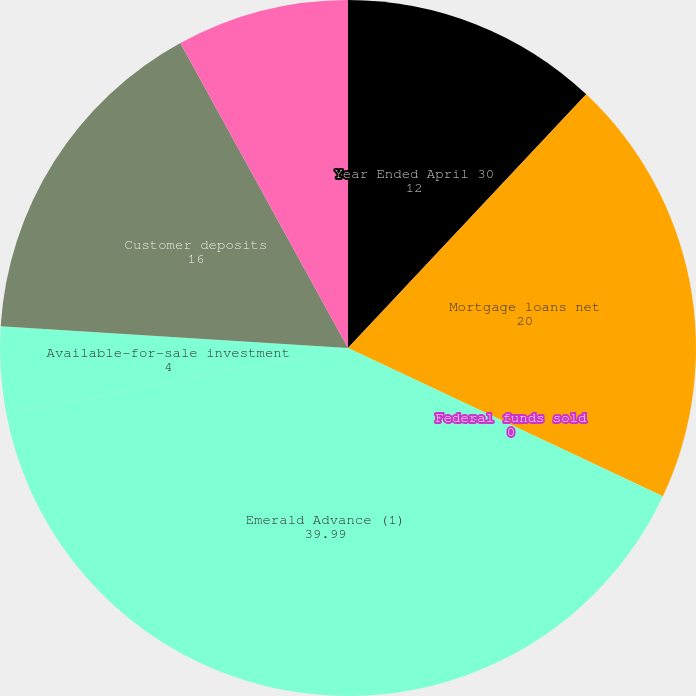<chart> <loc_0><loc_0><loc_500><loc_500><pie_chart><fcel>Year Ended April 30<fcel>Mortgage loans net<fcel>Federal funds sold<fcel>Emerald Advance (1)<fcel>Available-for-sale investment<fcel>Customer deposits<fcel>FHLB borrowing<nl><fcel>12.0%<fcel>20.0%<fcel>0.0%<fcel>39.99%<fcel>4.0%<fcel>16.0%<fcel>8.0%<nl></chart> 